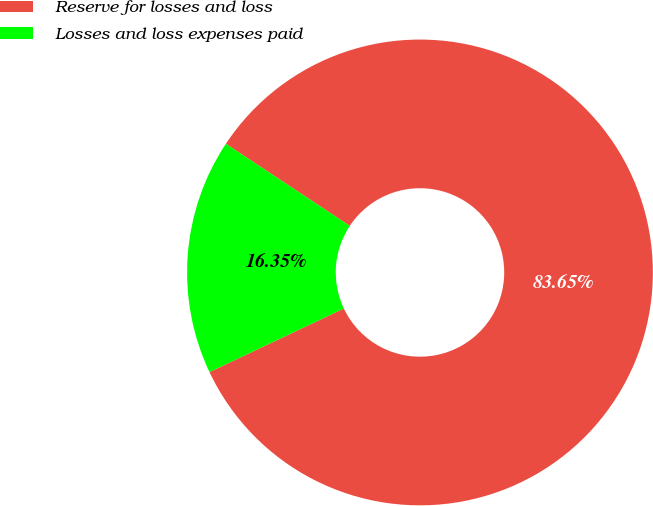<chart> <loc_0><loc_0><loc_500><loc_500><pie_chart><fcel>Reserve for losses and loss<fcel>Losses and loss expenses paid<nl><fcel>83.65%<fcel>16.35%<nl></chart> 